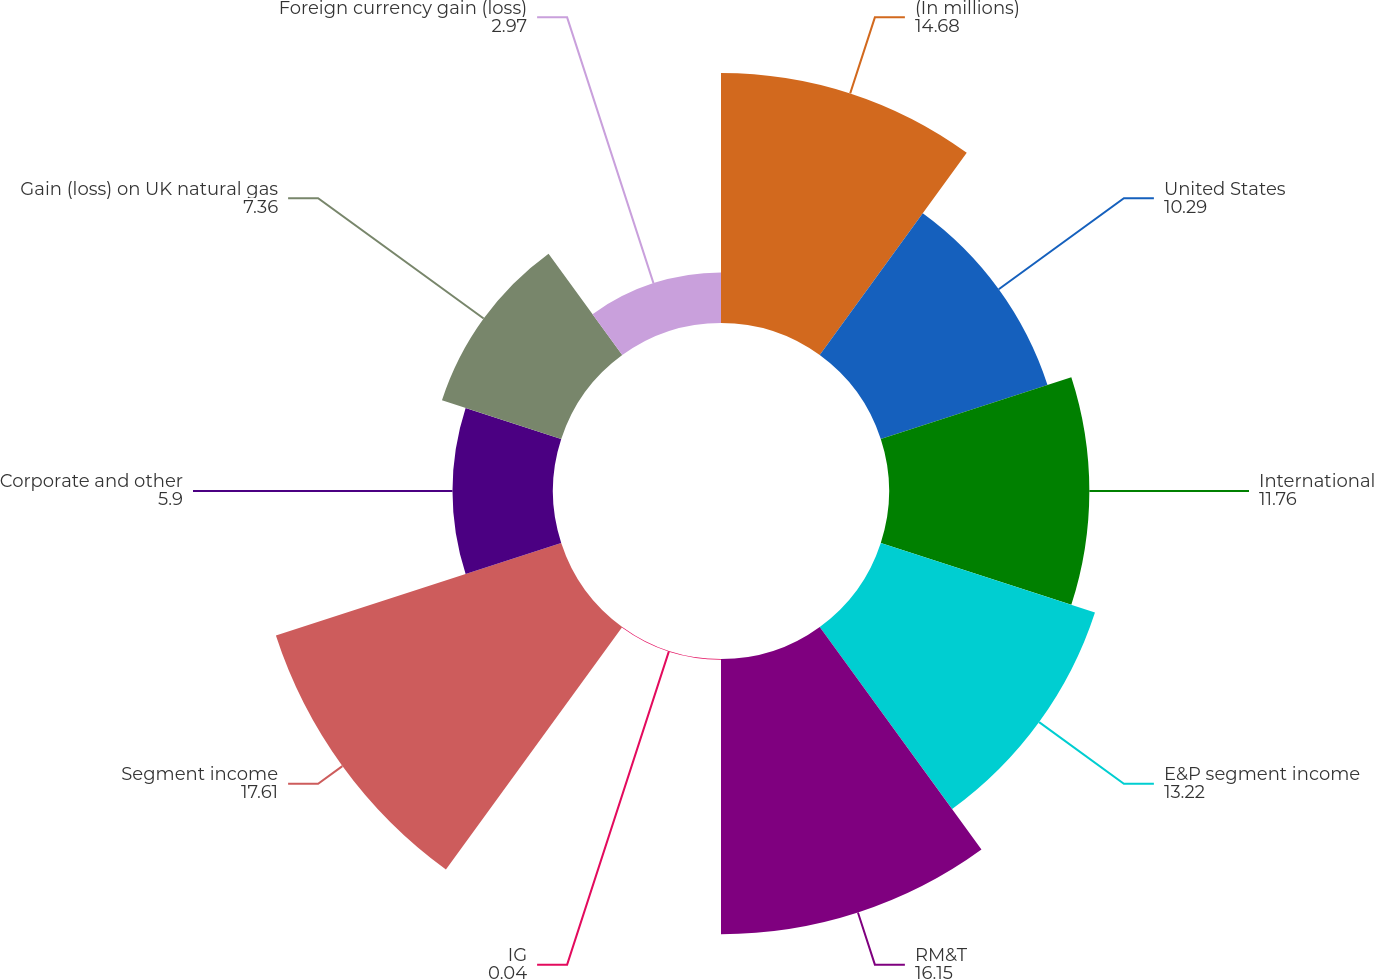<chart> <loc_0><loc_0><loc_500><loc_500><pie_chart><fcel>(In millions)<fcel>United States<fcel>International<fcel>E&P segment income<fcel>RM&T<fcel>IG<fcel>Segment income<fcel>Corporate and other<fcel>Gain (loss) on UK natural gas<fcel>Foreign currency gain (loss)<nl><fcel>14.68%<fcel>10.29%<fcel>11.76%<fcel>13.22%<fcel>16.15%<fcel>0.04%<fcel>17.61%<fcel>5.9%<fcel>7.36%<fcel>2.97%<nl></chart> 